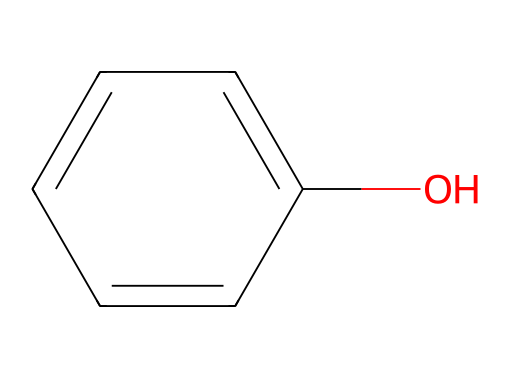What is the name of this chemical? The SMILES representation indicates a phenol structure, which contains a benzene ring with a hydroxyl group (-OH) attached. This specific structure leads to the common name "phenol."
Answer: phenol How many carbon atoms are in this molecule? By analyzing the SMILES representation, we see there are 6 carbon atoms in the benzene ring, which comprises the entire structure.
Answer: 6 What type of bonding is primarily present in this chemical? The structure consists of a benzene ring, which has delocalized π-electrons due to resonance involving the carbon-carbon bonds, making it primarily covalent bonding.
Answer: covalent What functional group is present in this chemical? The hydroxyl group (-OH) attached to the benzene ring indicates the presence of a functional group that characterizes phenols, specifically identifying it as a phenolic compound.
Answer: hydroxyl Is this compound a solid, liquid, or gas at room temperature? Phenol is known to be a solid at room temperature, specifically at about 25 degrees Celsius, indicating that its physical state is solid.
Answer: solid Does this chemical conduct electricity in solution? As a non-electrolyte, phenol does not dissociate into ions when dissolved in water, leading to the conclusion that it does not conduct electricity.
Answer: no 